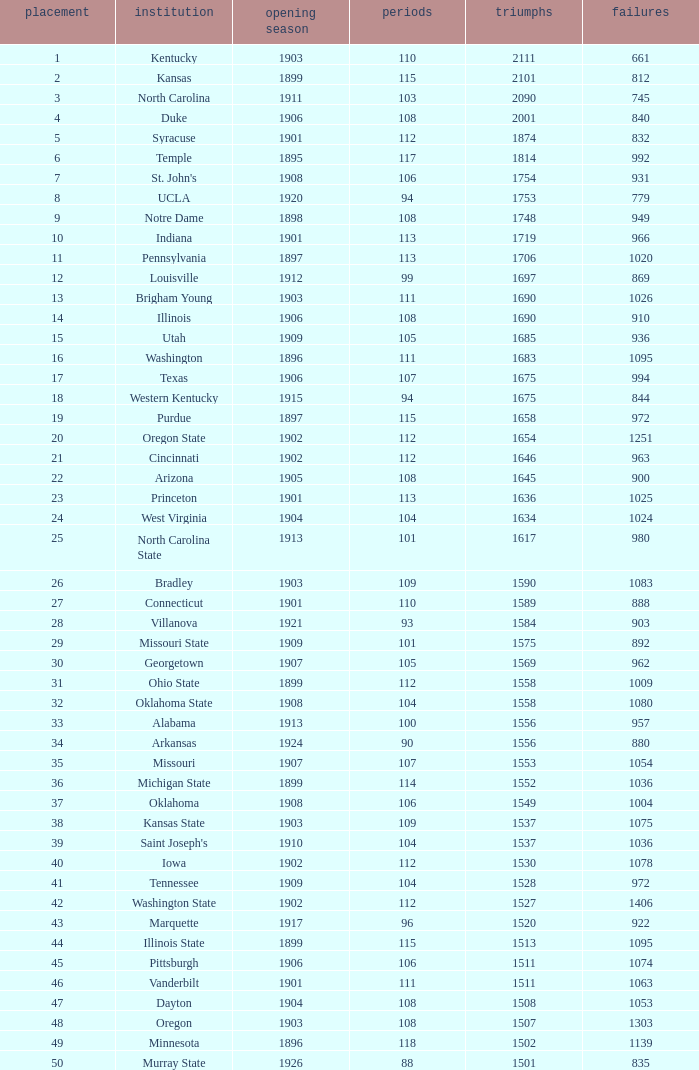How many wins were there for Washington State College with losses greater than 980 and a first season before 1906 and rank greater than 42? 0.0. 